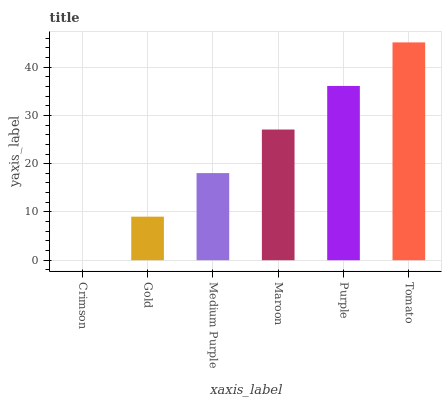Is Crimson the minimum?
Answer yes or no. Yes. Is Tomato the maximum?
Answer yes or no. Yes. Is Gold the minimum?
Answer yes or no. No. Is Gold the maximum?
Answer yes or no. No. Is Gold greater than Crimson?
Answer yes or no. Yes. Is Crimson less than Gold?
Answer yes or no. Yes. Is Crimson greater than Gold?
Answer yes or no. No. Is Gold less than Crimson?
Answer yes or no. No. Is Maroon the high median?
Answer yes or no. Yes. Is Medium Purple the low median?
Answer yes or no. Yes. Is Medium Purple the high median?
Answer yes or no. No. Is Gold the low median?
Answer yes or no. No. 